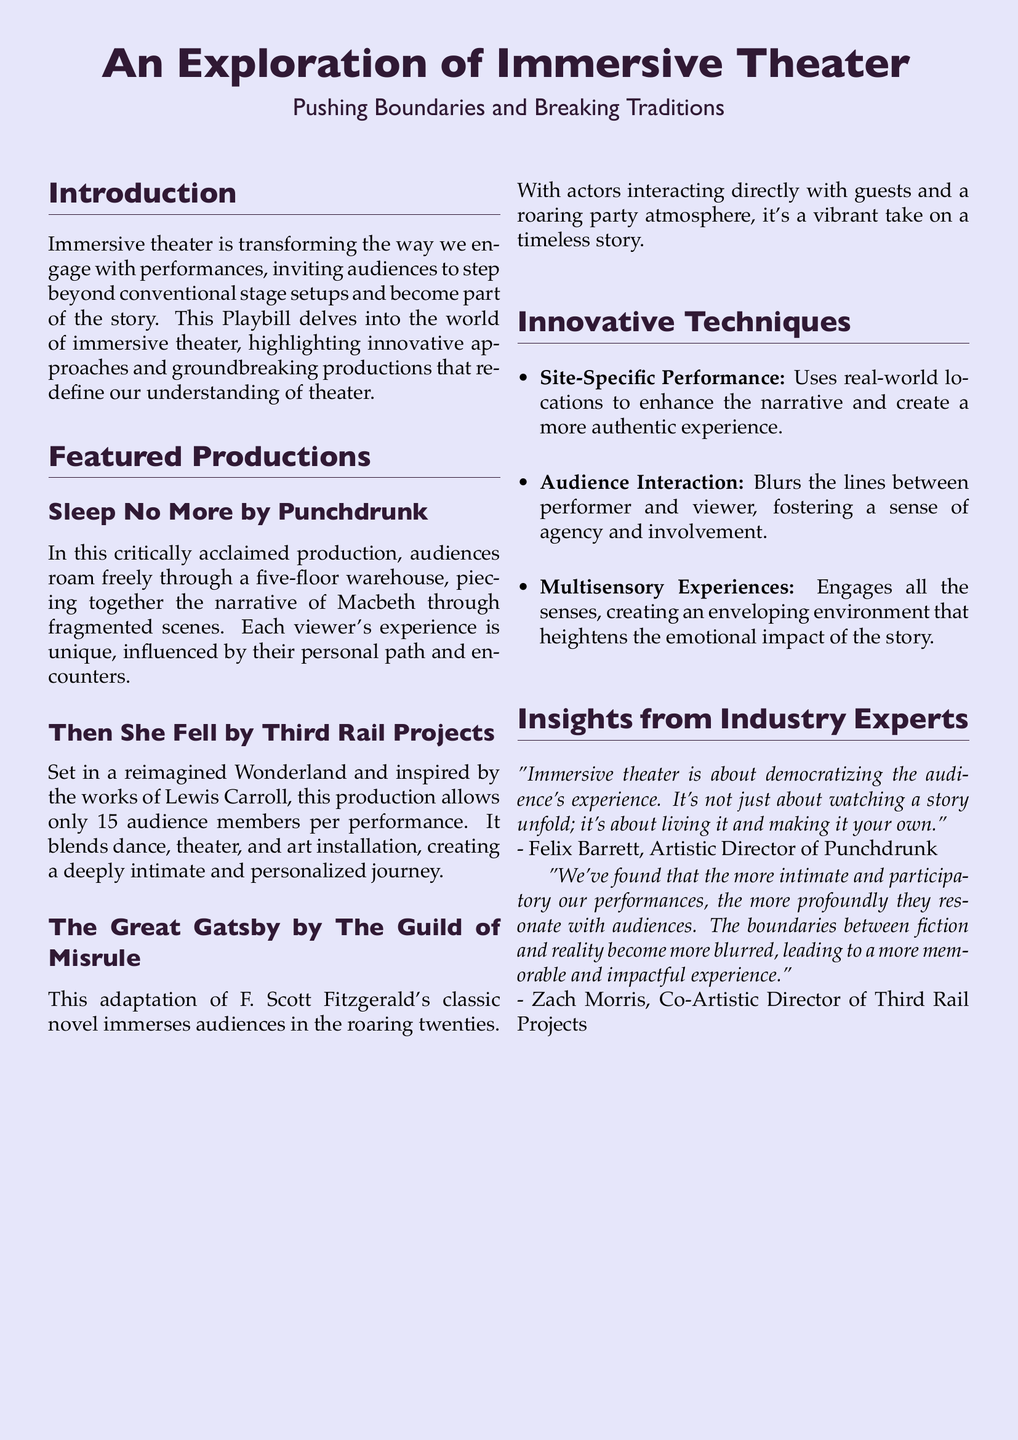What is the title of the play featured in the Playbill? The title of the play is stated at the top of the document as "An Exploration of Immersive Theater."
Answer: An Exploration of Immersive Theater Who created the production "Sleep No More"? The production "Sleep No More" was created by Punchdrunk, as mentioned in the featured productions section.
Answer: Punchdrunk How many audience members are allowed per performance in "Then She Fell"? The document specifies that only 15 audience members are allowed per performance in "Then She Fell."
Answer: 15 What type of performance technique uses real-world locations? The technique mentioned in the document is called Site-Specific Performance.
Answer: Site-Specific Performance Who is the Artistic Director of Punchdrunk? The Artistic Director of Punchdrunk is Felix Barrett, as cited in the insights section.
Answer: Felix Barrett What is one way immersive theater changes the audience's experience? The document states that immersive theater democratizes the audience's experience by allowing them to live the story rather than just watch it.
Answer: Living it How many floors does the venue for "Sleep No More" have? The production "Sleep No More" takes place in a five-floor warehouse.
Answer: Five Which production is based on a classic novel by F. Scott Fitzgerald? The production based on F. Scott Fitzgerald's classic novel is "The Great Gatsby."
Answer: The Great Gatsby What is emphasized in immersive theater according to industry experts? The industry experts emphasize that more intimate and participatory performances resonate more with audiences.
Answer: Intimate and participatory 